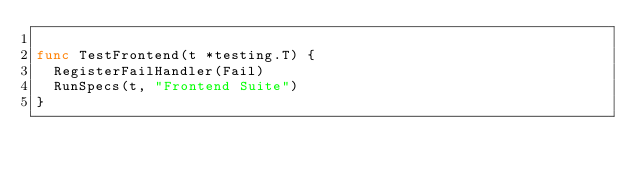Convert code to text. <code><loc_0><loc_0><loc_500><loc_500><_Go_>
func TestFrontend(t *testing.T) {
	RegisterFailHandler(Fail)
	RunSpecs(t, "Frontend Suite")
}
</code> 